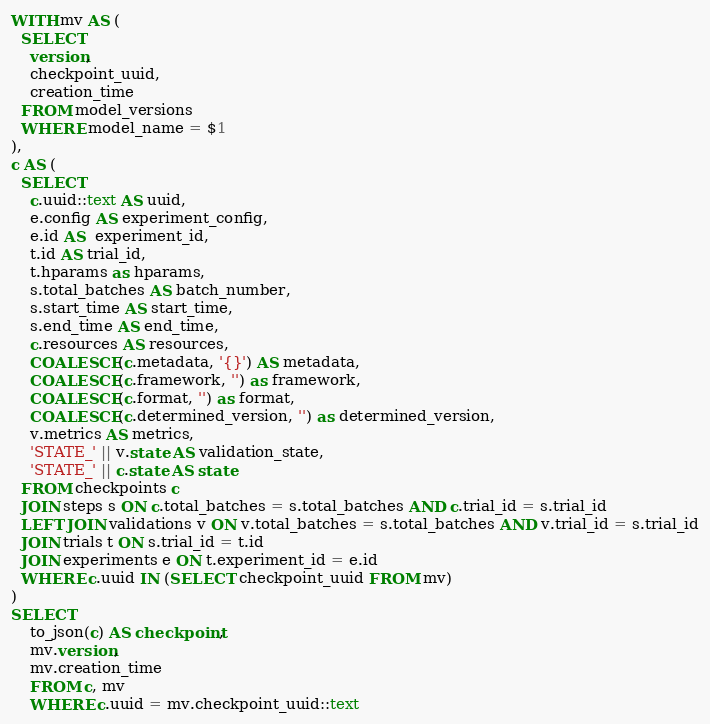Convert code to text. <code><loc_0><loc_0><loc_500><loc_500><_SQL_>WITH mv AS (
  SELECT
    version,
    checkpoint_uuid,
    creation_time
  FROM model_versions
  WHERE model_name = $1
),
c AS (
  SELECT
    c.uuid::text AS uuid,
    e.config AS experiment_config,
    e.id AS  experiment_id,
    t.id AS trial_id,
    t.hparams as hparams,
    s.total_batches AS batch_number,
    s.start_time AS start_time,
    s.end_time AS end_time,
    c.resources AS resources,
    COALESCE(c.metadata, '{}') AS metadata,
    COALESCE(c.framework, '') as framework,
    COALESCE(c.format, '') as format,
    COALESCE(c.determined_version, '') as determined_version,
    v.metrics AS metrics,
    'STATE_' || v.state AS validation_state,
    'STATE_' || c.state AS state
  FROM checkpoints c
  JOIN steps s ON c.total_batches = s.total_batches AND c.trial_id = s.trial_id
  LEFT JOIN validations v ON v.total_batches = s.total_batches AND v.trial_id = s.trial_id
  JOIN trials t ON s.trial_id = t.id
  JOIN experiments e ON t.experiment_id = e.id
  WHERE c.uuid IN (SELECT checkpoint_uuid FROM mv)
)
SELECT
    to_json(c) AS checkpoint,
    mv.version,
    mv.creation_time
    FROM c, mv
    WHERE c.uuid = mv.checkpoint_uuid::text
</code> 